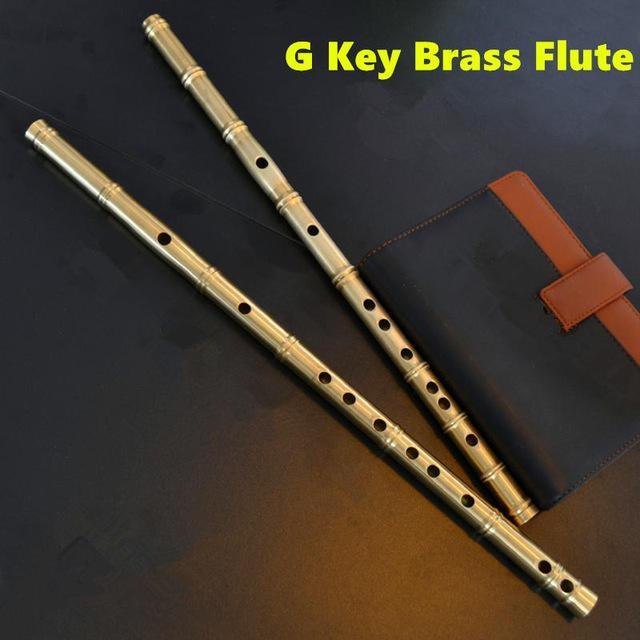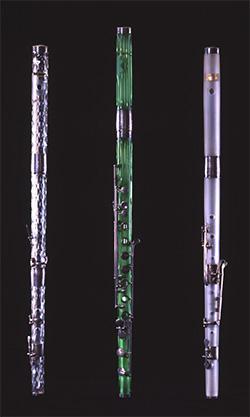The first image is the image on the left, the second image is the image on the right. For the images displayed, is the sentence "The right image contains exactly one flute like musical instrument." factually correct? Answer yes or no. No. 